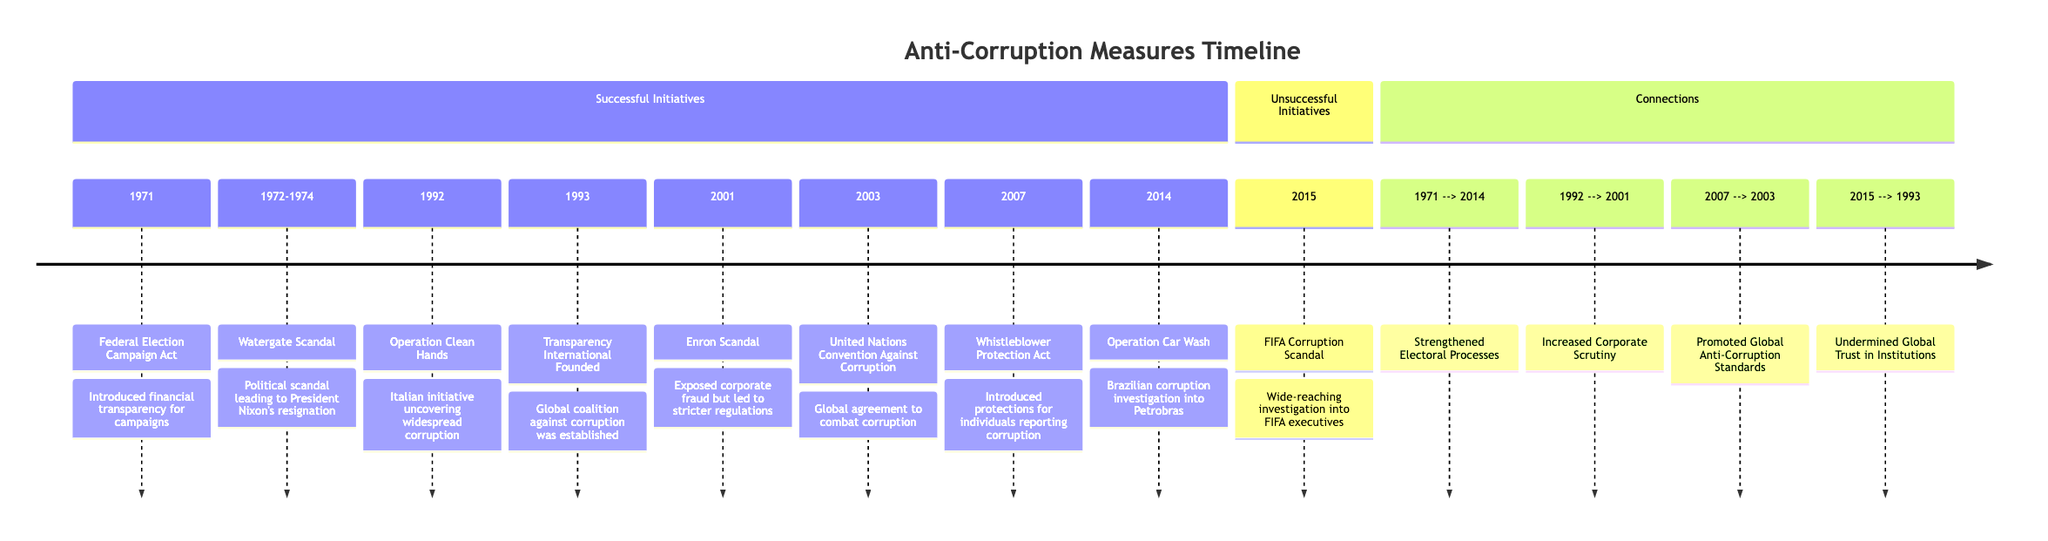What year was the United Nations Convention Against Corruption established? The diagram shows "2003" next to the United Nations Convention Against Corruption in the section for Successful Initiatives, indicating the year it was established.
Answer: 2003 How many successful initiatives are listed in the diagram? The section for Successful Initiatives contains eight entries, which can be counted directly from the timeline provided.
Answer: 8 What was the first successful initiative mentioned in the timeline? The first entry under Successful Initiatives is "1971: Federal Election Campaign Act," which indicates it was the earliest action taken noted in the diagram.
Answer: Federal Election Campaign Act Which two initiatives are connected by the arrow labeled "Strengthened Electoral Processes"? The timeline describes a connection from "1971" (Federal Election Campaign Act) to "2014" (Operation Car Wash), emphasizing the relationship between these two events.
Answer: Federal Election Campaign Act and Operation Car Wash What significant event in 2015 is marked as unsuccessful? In the Unsuccessful Initiatives section, "2015: FIFA Corruption Scandal" is clearly identified as a notable event that did not succeed.
Answer: FIFA Corruption Scandal Which year connects the introduction of the Whistleblower Protection Act and the United Nations Convention Against Corruption? The arrow in the diagram labeled "Promoted Global Anti-Corruption Standards" connects "2007" (Whistleblower Protection Act) to "2003" (United Nations Convention Against Corruption), indicating the relationship in that time frame.
Answer: 2003 How does the FIFA Corruption Scandal relate to the established anti-corruption efforts? The diagram links "2015" (FIFA Corruption Scandal) to "1993" (Transparency International Founded) with the note "Undermined Global Trust in Institutions," describing the negative impact this scandal had on prior efforts.
Answer: Undermined Global Trust in Institutions What event occurred between 1992 and 2001 that led to increased scrutiny on corporations? The timeline shows a connection from "1992" (Operation Clean Hands) to "2001" (Enron Scandal) illustrating an increase in focus on corporate accountability during that time period.
Answer: Increased Corporate Scrutiny 